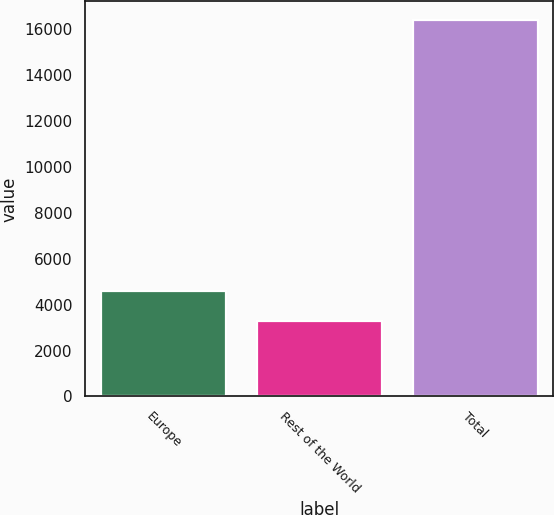Convert chart to OTSL. <chart><loc_0><loc_0><loc_500><loc_500><bar_chart><fcel>Europe<fcel>Rest of the World<fcel>Total<nl><fcel>4604<fcel>3295<fcel>16385<nl></chart> 